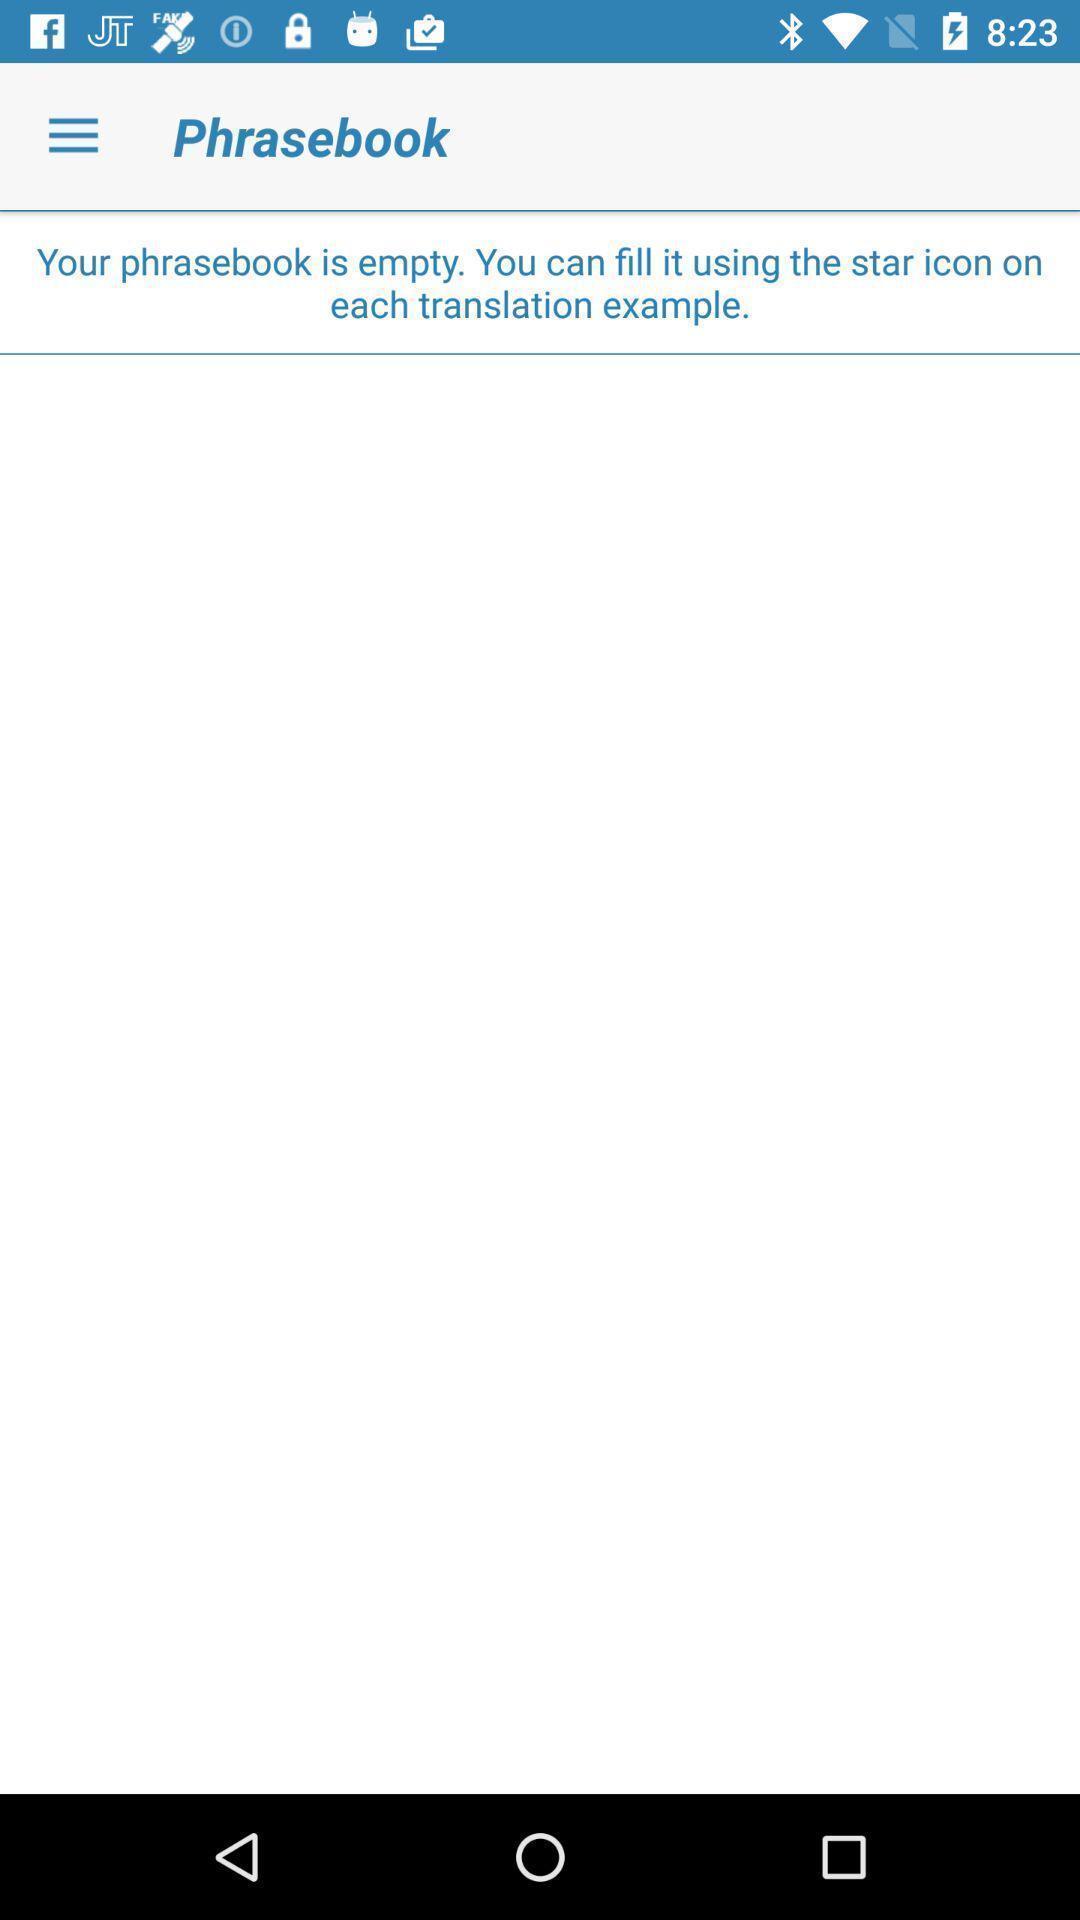Tell me what you see in this picture. Screen displaying phrasebook page of a translation app. 